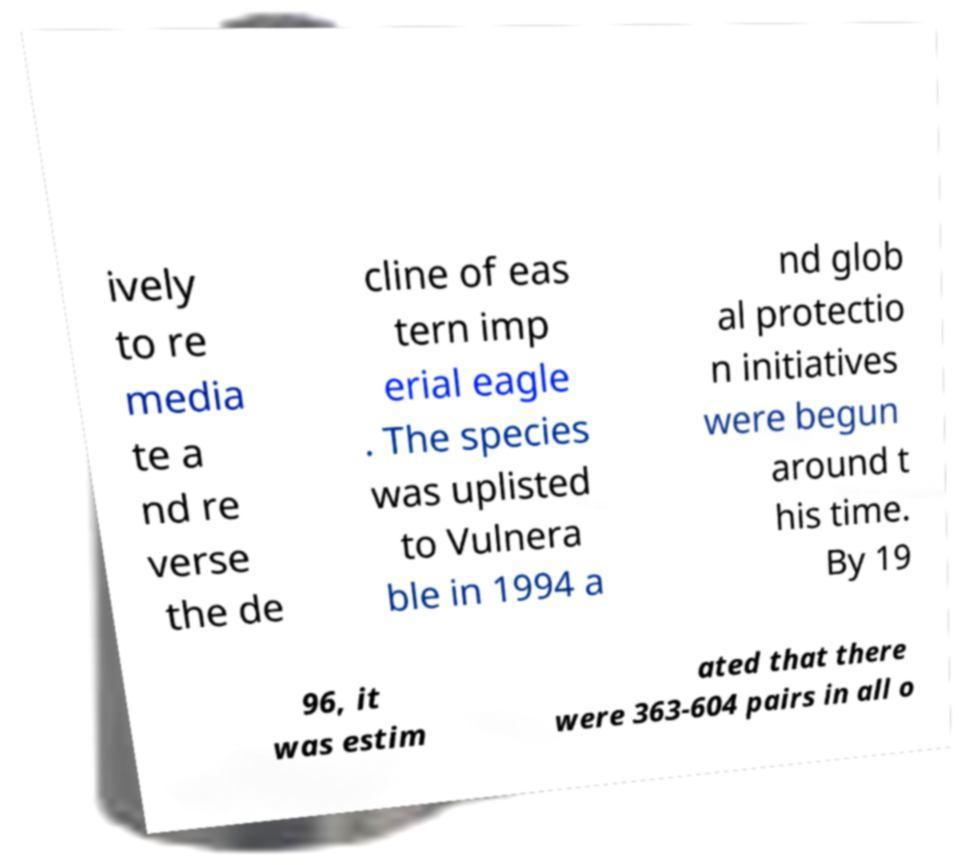Can you accurately transcribe the text from the provided image for me? ively to re media te a nd re verse the de cline of eas tern imp erial eagle . The species was uplisted to Vulnera ble in 1994 a nd glob al protectio n initiatives were begun around t his time. By 19 96, it was estim ated that there were 363-604 pairs in all o 